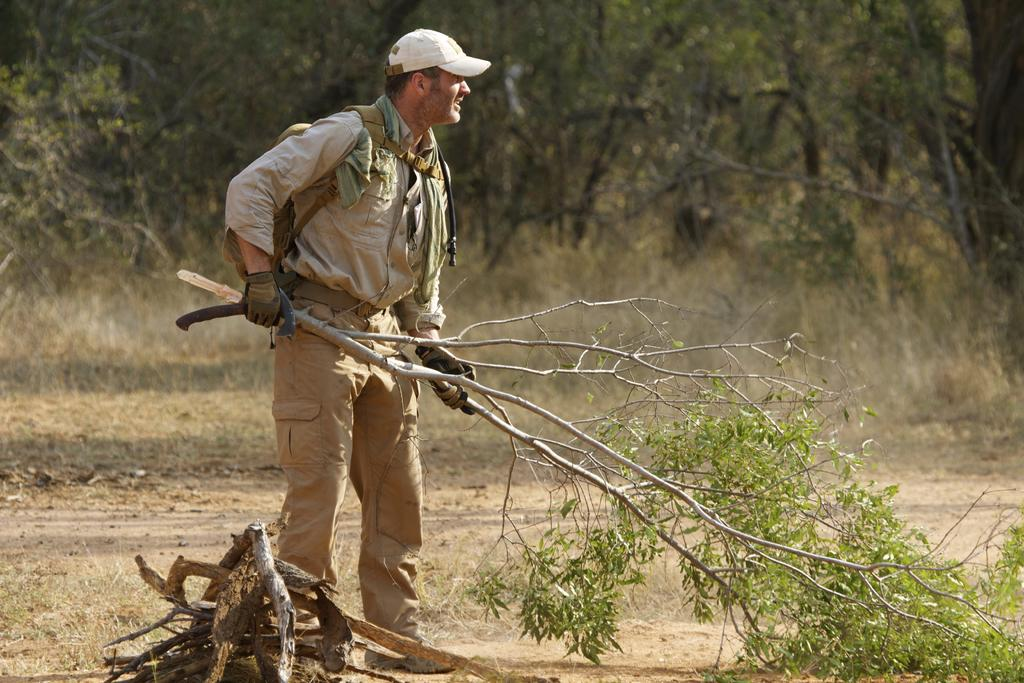What is the main subject of the image? There is a person standing in the center of the image. What is the person holding in the image? The person is holding a tree. What can be seen in the background of the image? There are trees and plants in the background of the image. What type of toy can be seen on the farm in the image? There is no farm or toy present in the image. 